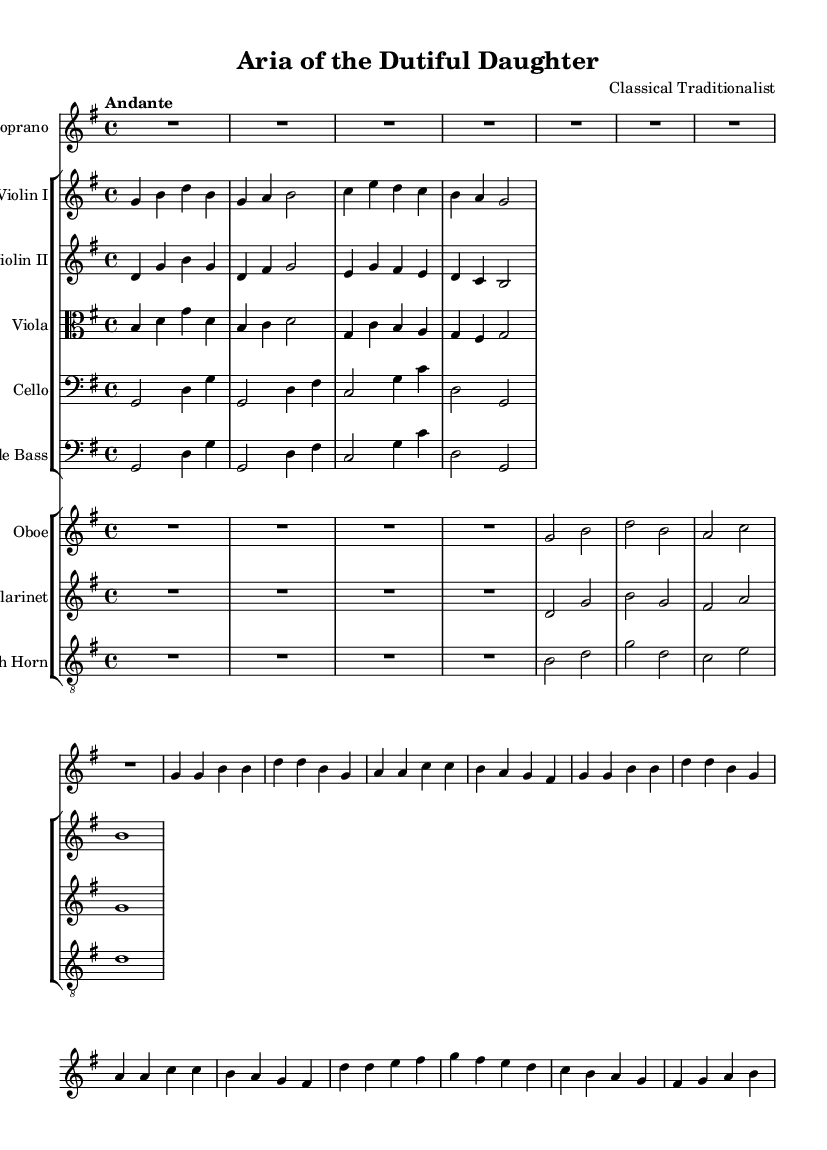What is the key signature of this music? The key signature is indicated at the beginning of the score, which shows one sharp. This corresponds to G major.
Answer: G major What is the time signature of the piece? The time signature is displayed at the beginning of the score and reads 4/4, meaning there are four beats per measure.
Answer: 4/4 What is the tempo marking for this piece? The tempo instruction is indicated in the score, where it states "Andante." This is a common tempo marking that suggests a moderate pace.
Answer: Andante How many measures are in the soprano voice part? The soprano voice part has a total of 12 measures, counted from the beginning to the end of the part.
Answer: 12 Which instrument plays the highest notes in this score? By examining the overall range of the instruments listed, the soprano voice typically has the highest pitch range compared to other instruments in the score.
Answer: Soprano What dynamics are indicated for the soprano voice? The dynamics are indicated with symbols in the soprano part; in this case, it starts with a dynamic marking indicating "up," which refers to the placement of the dynamic signs.
Answer: Up Which instruments are grouped together in this orchestral score? The score groups instruments into two main categories: strings (including violin I, violin II, viola, cello, and double bass) and woodwinds (oboe, clarinet, and French horn).
Answer: Strings and woodwinds 